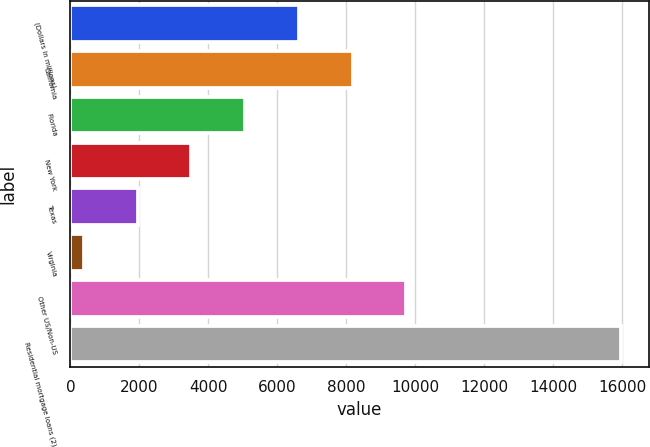Convert chart. <chart><loc_0><loc_0><loc_500><loc_500><bar_chart><fcel>(Dollars in millions)<fcel>California<fcel>Florida<fcel>New York<fcel>Texas<fcel>Virginia<fcel>Other US/Non-US<fcel>Residential mortgage loans (2)<nl><fcel>6627.4<fcel>8184.5<fcel>5070.3<fcel>3513.2<fcel>1956.1<fcel>399<fcel>9741.6<fcel>15970<nl></chart> 